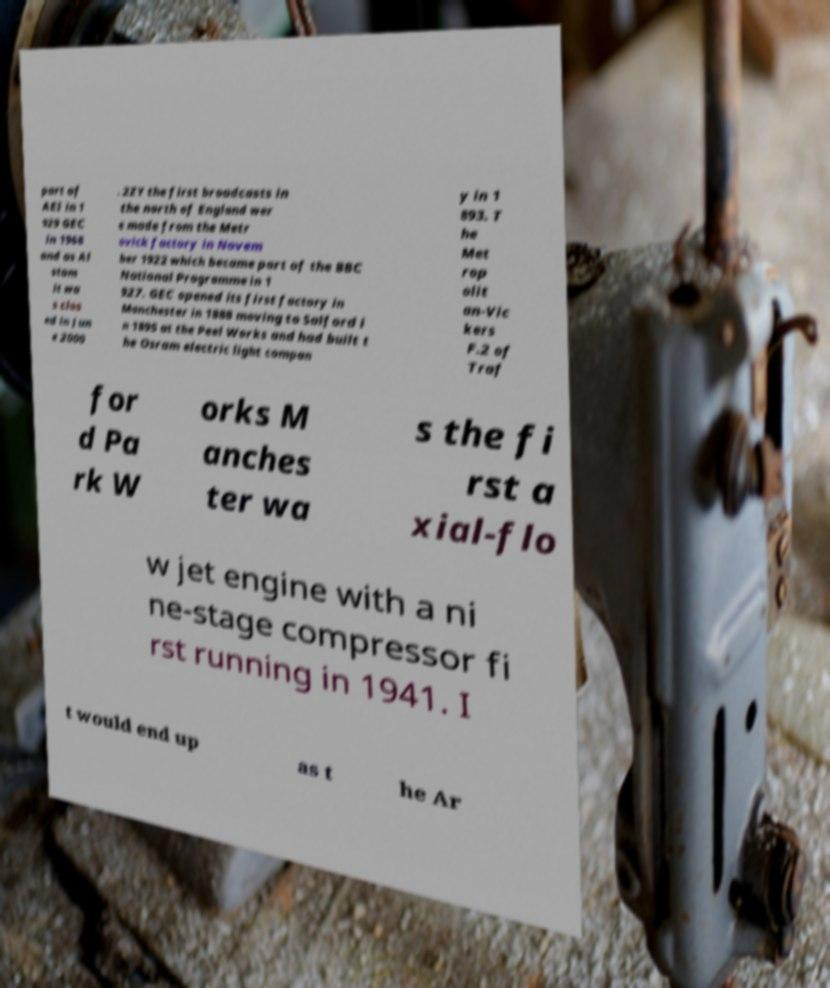For documentation purposes, I need the text within this image transcribed. Could you provide that? part of AEI in 1 929 GEC in 1968 and as Al stom it wa s clos ed in Jun e 2000 . 2ZY the first broadcasts in the north of England wer e made from the Metr ovick factory in Novem ber 1922 which became part of the BBC National Programme in 1 927. GEC opened its first factory in Manchester in 1888 moving to Salford i n 1895 at the Peel Works and had built t he Osram electric light compan y in 1 893. T he Met rop olit an-Vic kers F.2 of Traf for d Pa rk W orks M anches ter wa s the fi rst a xial-flo w jet engine with a ni ne-stage compressor fi rst running in 1941. I t would end up as t he Ar 